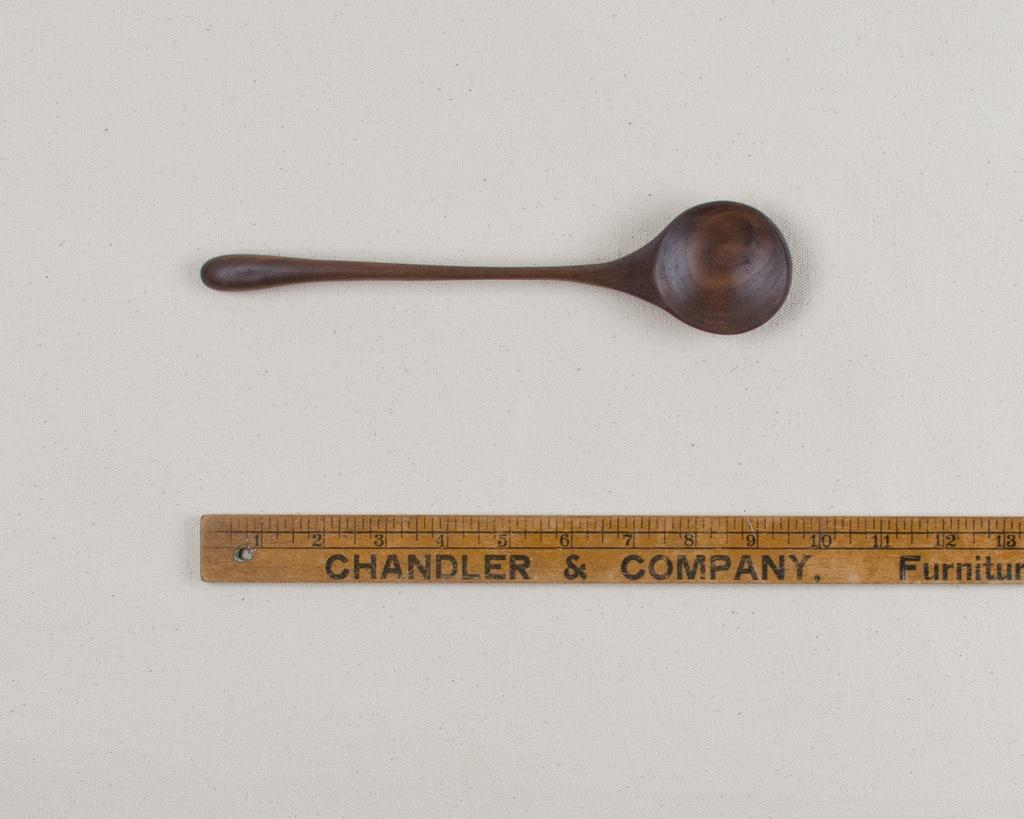<image>
Share a concise interpretation of the image provided. a ruler that has the word Chandler on it 